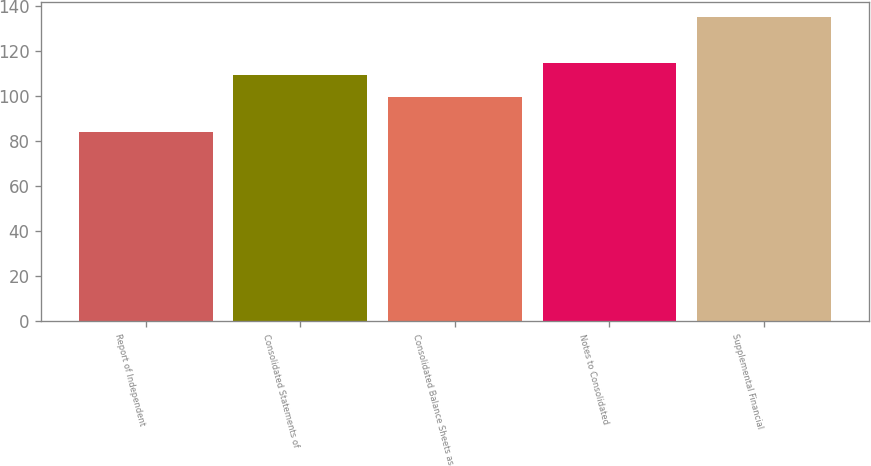<chart> <loc_0><loc_0><loc_500><loc_500><bar_chart><fcel>Report of Independent<fcel>Consolidated Statements of<fcel>Consolidated Balance Sheets as<fcel>Notes to Consolidated<fcel>Supplemental Financial<nl><fcel>84<fcel>109.5<fcel>99.3<fcel>114.6<fcel>135<nl></chart> 